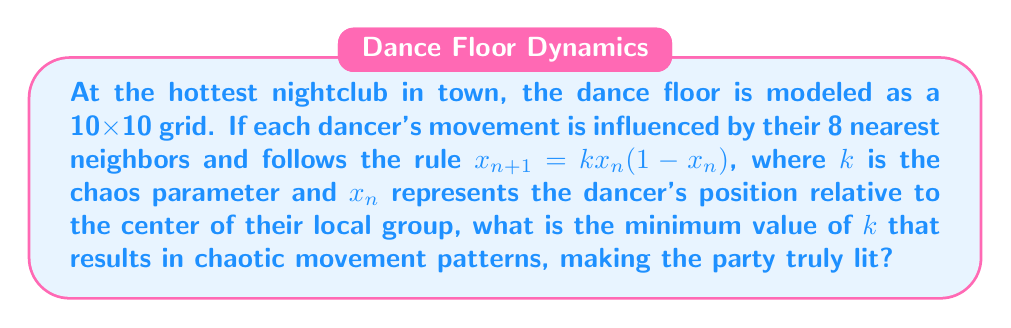Can you answer this question? To solve this problem, we need to understand the logistic map and its behavior in chaos theory:

1. The equation $x_{n+1} = kx_n(1-x_n)$ is known as the logistic map.

2. The behavior of this system depends on the value of $k$:
   - For $0 < k < 1$, the system converges to 0.
   - For $1 < k < 3$, the system converges to a single non-zero value.
   - For $3 < k < 3.57$, the system oscillates between multiple values.
   - For $k > 3.57$, the system exhibits chaotic behavior.

3. The transition to chaos occurs at approximately $k = 3.57$.

4. In the context of our dance floor model:
   - $x_n$ represents a dancer's position relative to their local group center.
   - $k$ represents the intensity of influence from neighboring dancers.

5. For the party to be "truly lit" with chaotic movement, we need the minimum value of $k$ that results in chaos.

6. Therefore, the minimum value of $k$ that leads to chaotic behavior is approximately 3.57.
Answer: $k \approx 3.57$ 